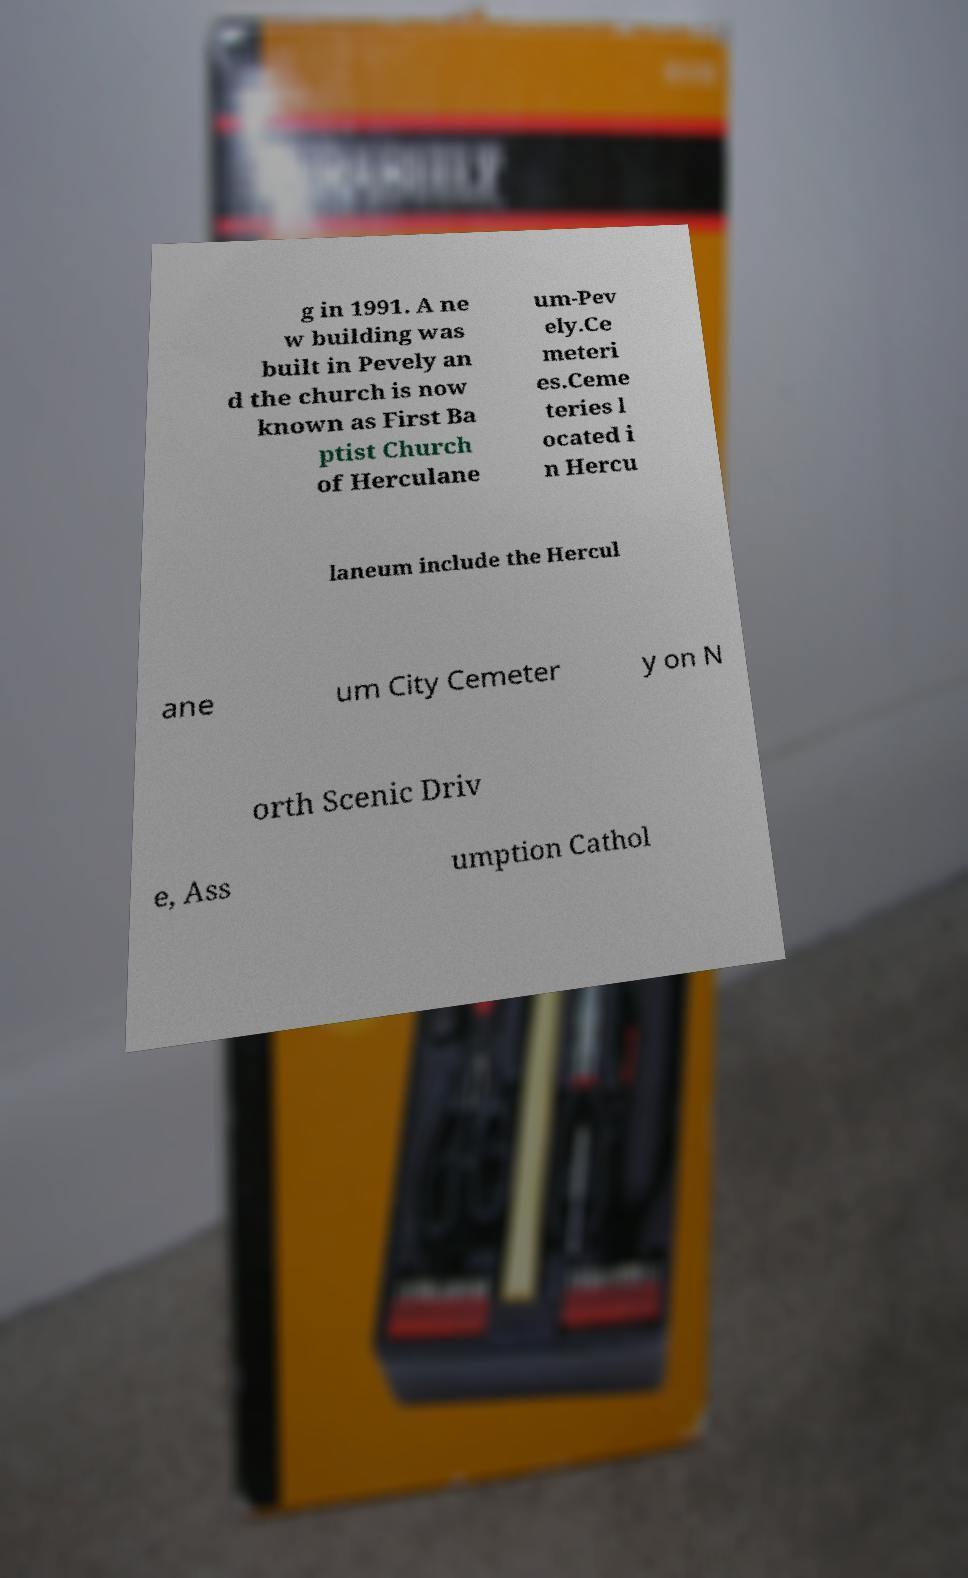What messages or text are displayed in this image? I need them in a readable, typed format. g in 1991. A ne w building was built in Pevely an d the church is now known as First Ba ptist Church of Herculane um-Pev ely.Ce meteri es.Ceme teries l ocated i n Hercu laneum include the Hercul ane um City Cemeter y on N orth Scenic Driv e, Ass umption Cathol 